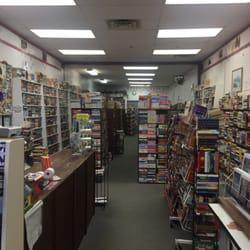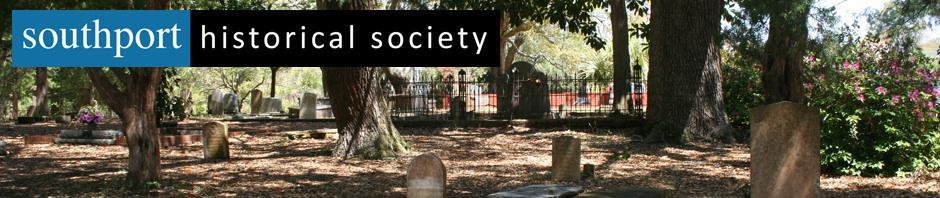The first image is the image on the left, the second image is the image on the right. Assess this claim about the two images: "In at least one image there is a door and two window at the front of the bookstore.". Correct or not? Answer yes or no. No. The first image is the image on the left, the second image is the image on the right. Analyze the images presented: Is the assertion "There are human beings visible in at least one image." valid? Answer yes or no. No. 